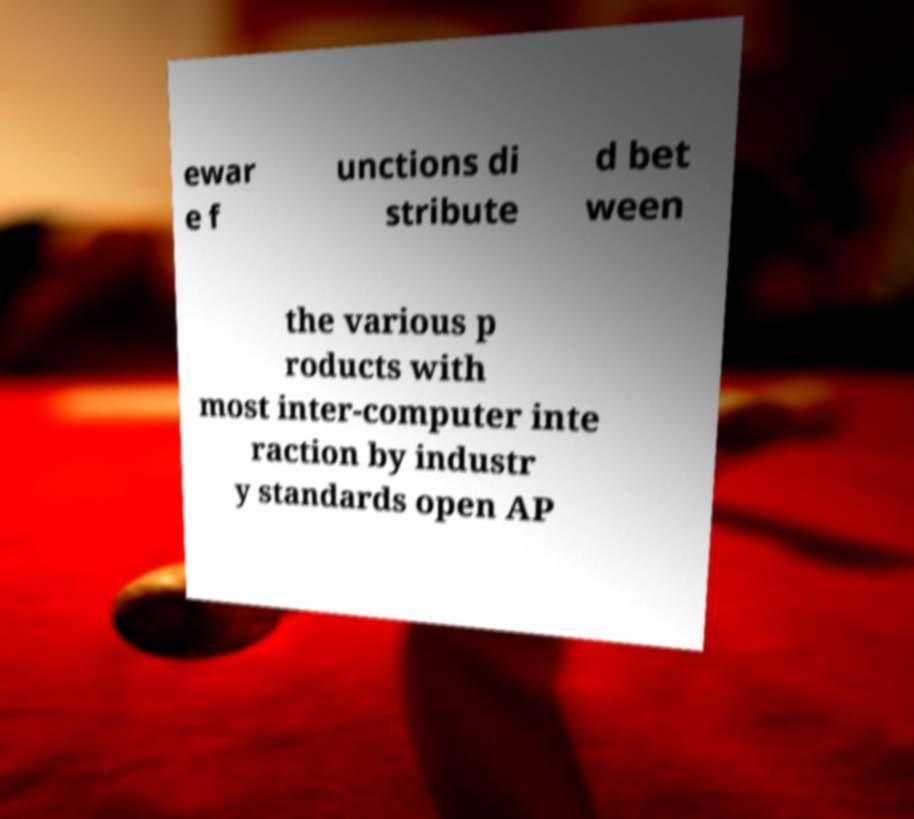Please read and relay the text visible in this image. What does it say? ewar e f unctions di stribute d bet ween the various p roducts with most inter-computer inte raction by industr y standards open AP 